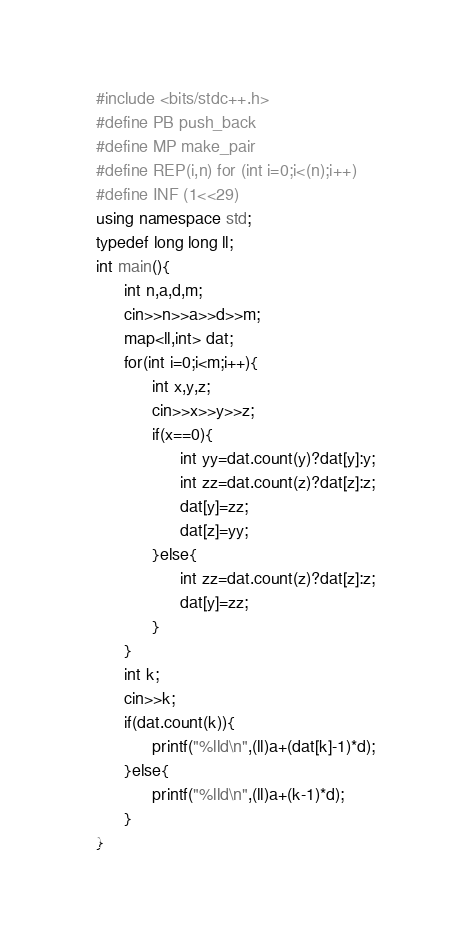Convert code to text. <code><loc_0><loc_0><loc_500><loc_500><_C++_>#include <bits/stdc++.h>
#define PB push_back
#define MP make_pair
#define REP(i,n) for (int i=0;i<(n);i++)
#define INF (1<<29)
using namespace std;
typedef long long ll;
int main(){
      int n,a,d,m;
      cin>>n>>a>>d>>m;
      map<ll,int> dat;
      for(int i=0;i<m;i++){
            int x,y,z;
            cin>>x>>y>>z;
            if(x==0){
                  int yy=dat.count(y)?dat[y]:y;
                  int zz=dat.count(z)?dat[z]:z;
                  dat[y]=zz;
                  dat[z]=yy;
            }else{
                  int zz=dat.count(z)?dat[z]:z;
                  dat[y]=zz;
            }
      }
      int k;
      cin>>k;
      if(dat.count(k)){
            printf("%lld\n",(ll)a+(dat[k]-1)*d);
      }else{
            printf("%lld\n",(ll)a+(k-1)*d);
      }
}</code> 